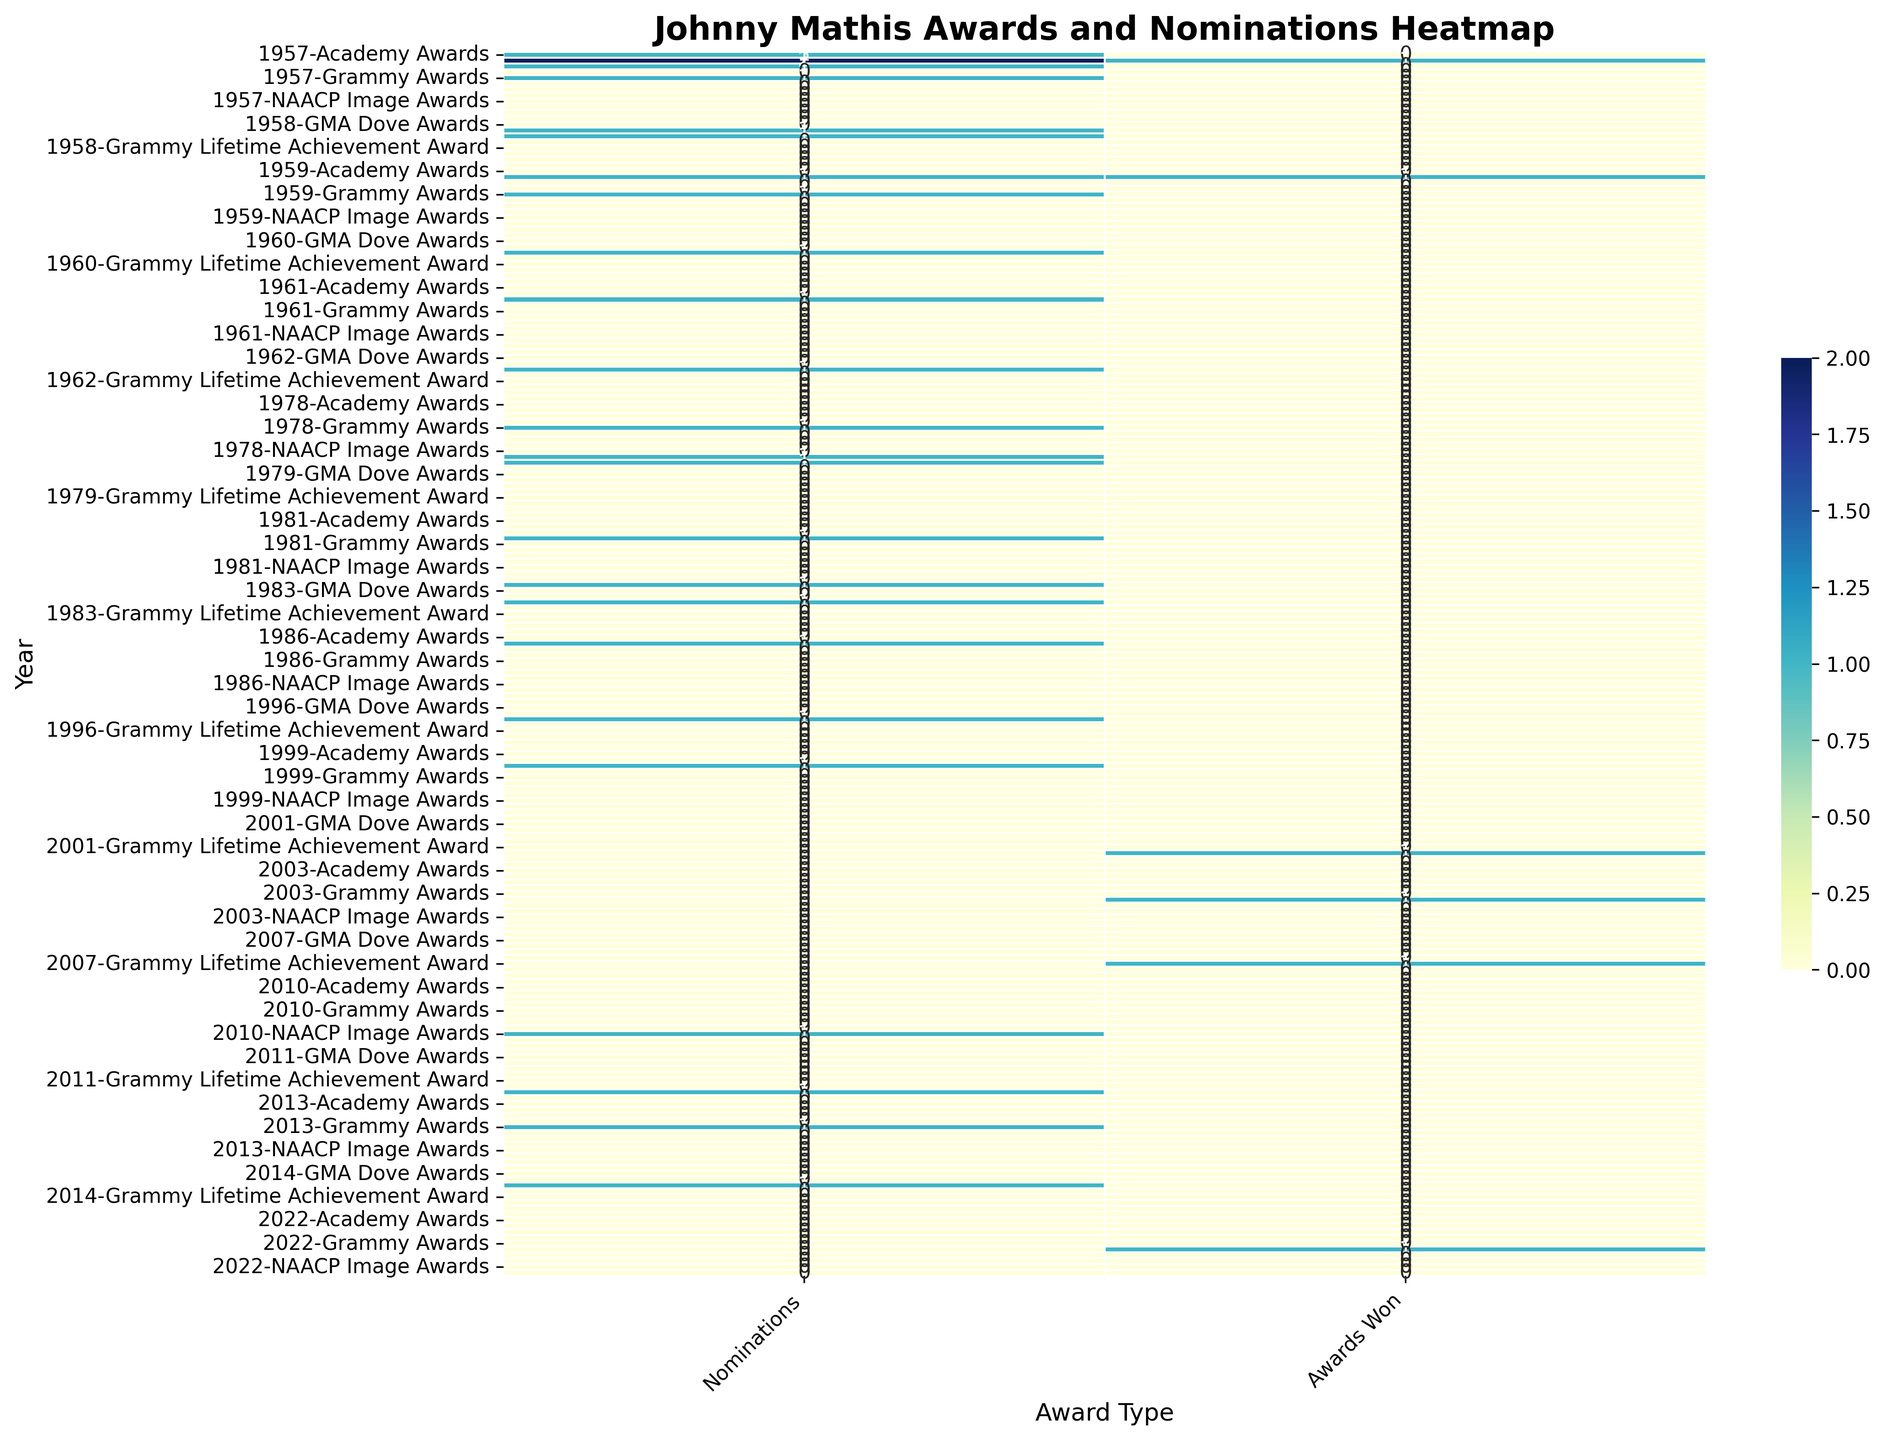What year did Johnny Mathis win the Grammy Lifetime Achievement Award? The heatmap shows "1" in the "Awards Won" column for the Grammy Lifetime Achievement Award in the row labeled 2007. This means Johnny Mathis won the Grammy Lifetime Achievement Award in 2007.
Answer: 2007 Which year had the highest number of Johnny Mathis' nominations in the American Music Awards? By scanning the figure, we observe that 1957 has the highest nominations with "2" in the American Music Awards column.
Answer: 1957 How many Grammy Hall of Fame awards did Johnny Mathis win, and in what years? By looking at the heatmap, we see "1" in the "Awards Won" column for the Grammy Hall of Fame in both 2003 and 2022. Summing these up gives us a total of 2 awards in the years 2003 and 2022.
Answer: 2, 2003 and 2022 Compare the total number of nominations and awards won by Johnny Mathis in the Golden Globe Awards to the TV Land Awards. Which award type had more nominations and which had more awards won? Counting from the heatmap, the Golden Globe Awards have "2" nominations and "0" awards won, while the TV Land Awards have "1" nomination and "0" awards won. The Golden Globe Awards had more nominations and both had the same number of awards won.
Answer: Golden Globe Awards, equal What is the difference between the total awards won and nominations for the NAACP Image Awards? Summing the values, "1" in "Nominations" for 2010 and "1" in 2011 for the NAACP Image Awards, we get 2 nominations. There are no awards won. The difference is 2 - 0 = 2.
Answer: 2 Calculate the mean number of nominations across all the Grammys Johnny Mathis has received. By adding the Grammy nominations from the heatmap (1+1+1+1+1+1+1+1+1), we get 9. There are 9 years of nominations, so the mean is 9 / 9 = 1.
Answer: 1 Which year has the highest overall total (sum of nominations and awards won across all award types) for Johnny Mathis? By summing nominations and awards for each year and comparing: 1957 = 1+1+2+1 = 5, 1958 = 1+1 = 2, 1959 = 1+1 = 2, etc. 1957 has the highest total with 5.
Answer: 1957 In which years did Johnny Mathis receive nominations but did not win any awards? Checking the heatmap, these years have nominations but no awards won: 1957, 1958, 1959, 1960, 1962, 1978 (Grammy & TV Land), 1979, 1981, 1983, 1986, 1996, 2010, 2011, 2013, 2014, and 1999.
Answer: Multiple years including 1957, 1958, and 2013 Which had more occurrences in Johnny Mathis’s career, Grammy nominations or American Music Awards nominations? Summing from the heatmap, Grammy nominations total "9" and American Music Awards nominations total "5". Grammys had more nominations.
Answer: Grammys 